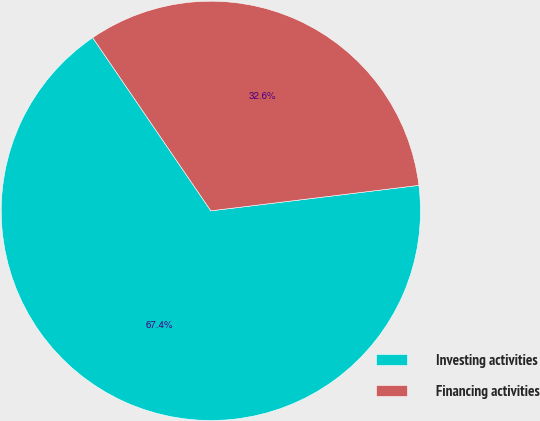Convert chart. <chart><loc_0><loc_0><loc_500><loc_500><pie_chart><fcel>Investing activities<fcel>Financing activities<nl><fcel>67.41%<fcel>32.59%<nl></chart> 